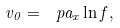<formula> <loc_0><loc_0><loc_500><loc_500>v _ { 0 } = \ p a _ { x } \ln f ,</formula> 